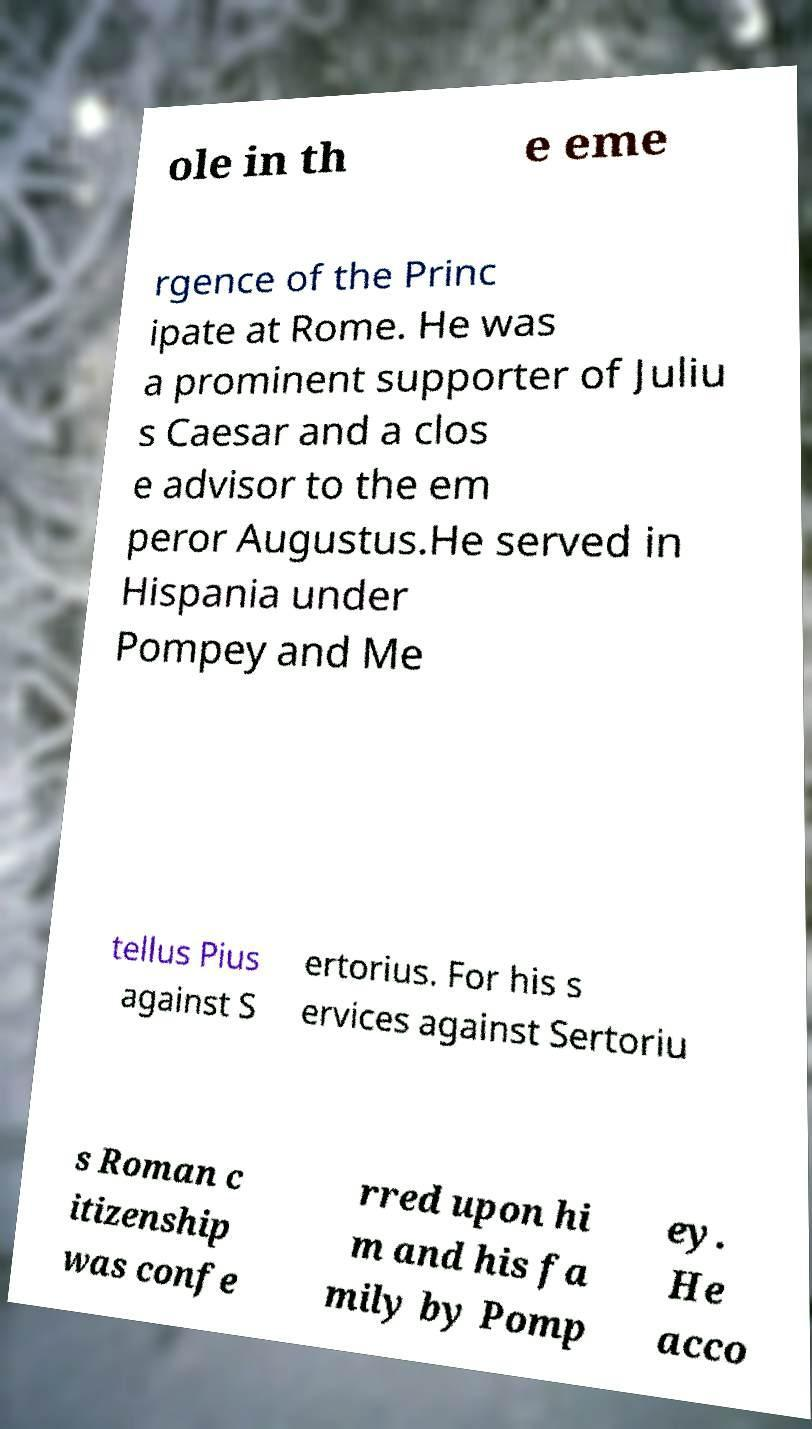Could you extract and type out the text from this image? ole in th e eme rgence of the Princ ipate at Rome. He was a prominent supporter of Juliu s Caesar and a clos e advisor to the em peror Augustus.He served in Hispania under Pompey and Me tellus Pius against S ertorius. For his s ervices against Sertoriu s Roman c itizenship was confe rred upon hi m and his fa mily by Pomp ey. He acco 